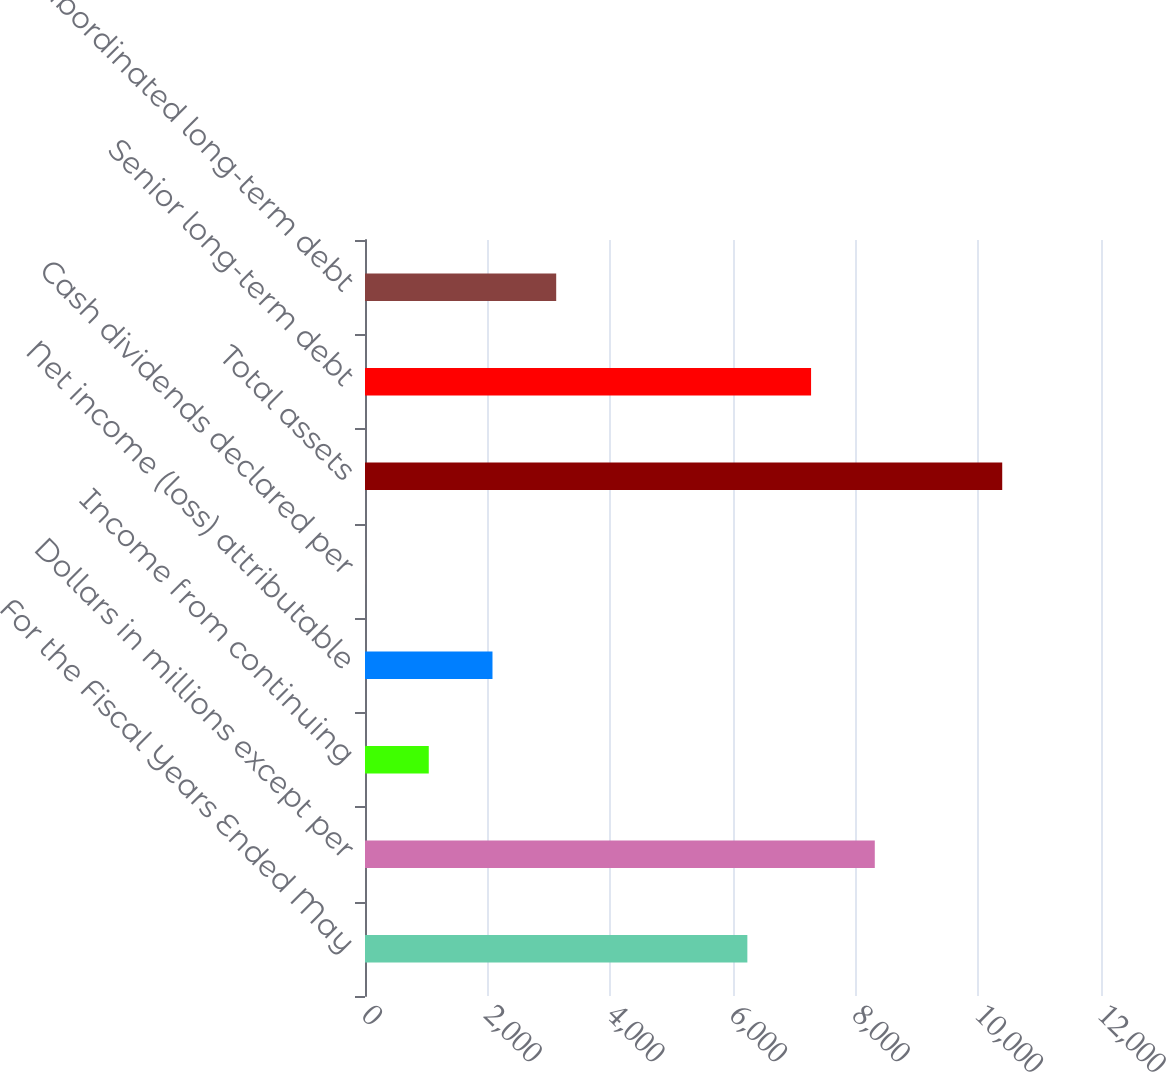Convert chart. <chart><loc_0><loc_0><loc_500><loc_500><bar_chart><fcel>For the Fiscal Years Ended May<fcel>Dollars in millions except per<fcel>Income from continuing<fcel>Net income (loss) attributable<fcel>Cash dividends declared per<fcel>Total assets<fcel>Senior long-term debt<fcel>Subordinated long-term debt<nl><fcel>6234.05<fcel>8311.77<fcel>1039.71<fcel>2078.57<fcel>0.85<fcel>10389.5<fcel>7272.91<fcel>3117.44<nl></chart> 